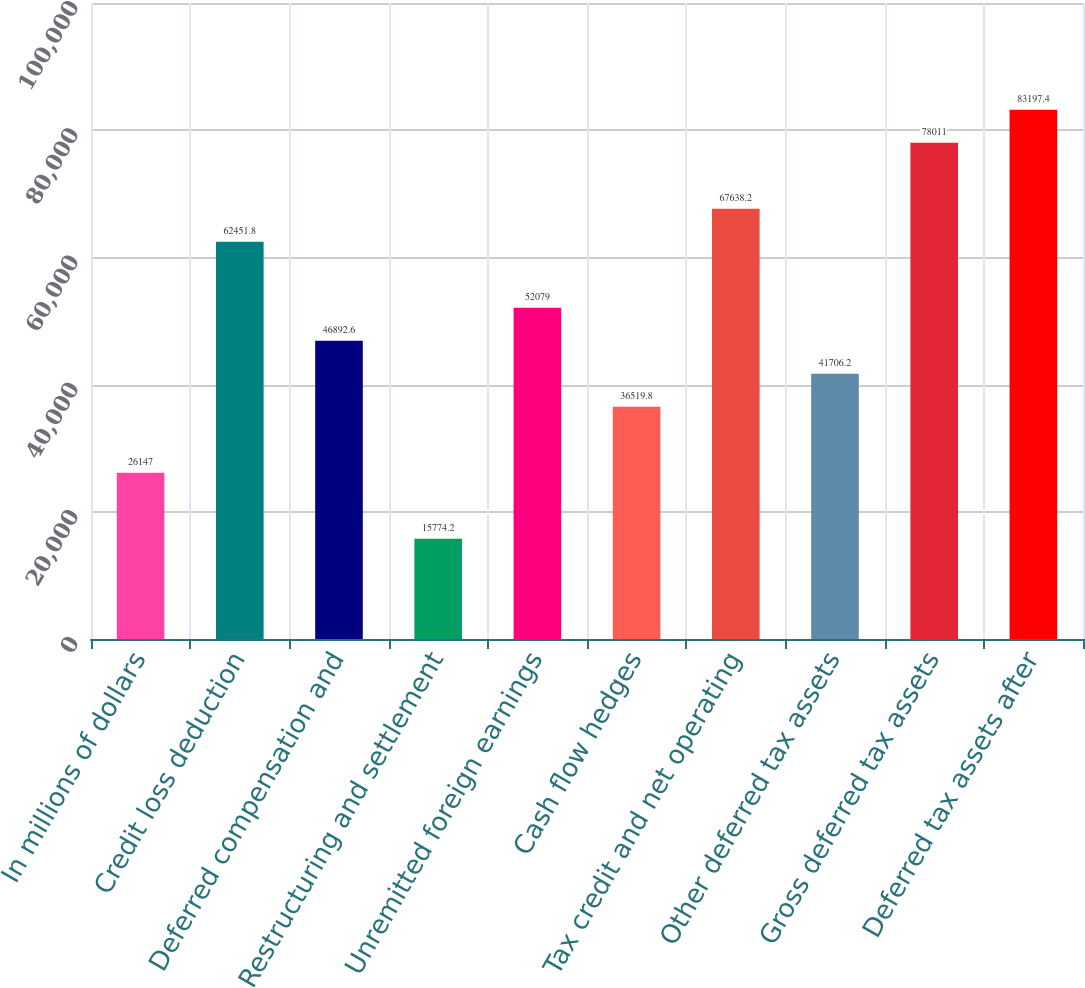Convert chart to OTSL. <chart><loc_0><loc_0><loc_500><loc_500><bar_chart><fcel>In millions of dollars<fcel>Credit loss deduction<fcel>Deferred compensation and<fcel>Restructuring and settlement<fcel>Unremitted foreign earnings<fcel>Cash flow hedges<fcel>Tax credit and net operating<fcel>Other deferred tax assets<fcel>Gross deferred tax assets<fcel>Deferred tax assets after<nl><fcel>26147<fcel>62451.8<fcel>46892.6<fcel>15774.2<fcel>52079<fcel>36519.8<fcel>67638.2<fcel>41706.2<fcel>78011<fcel>83197.4<nl></chart> 